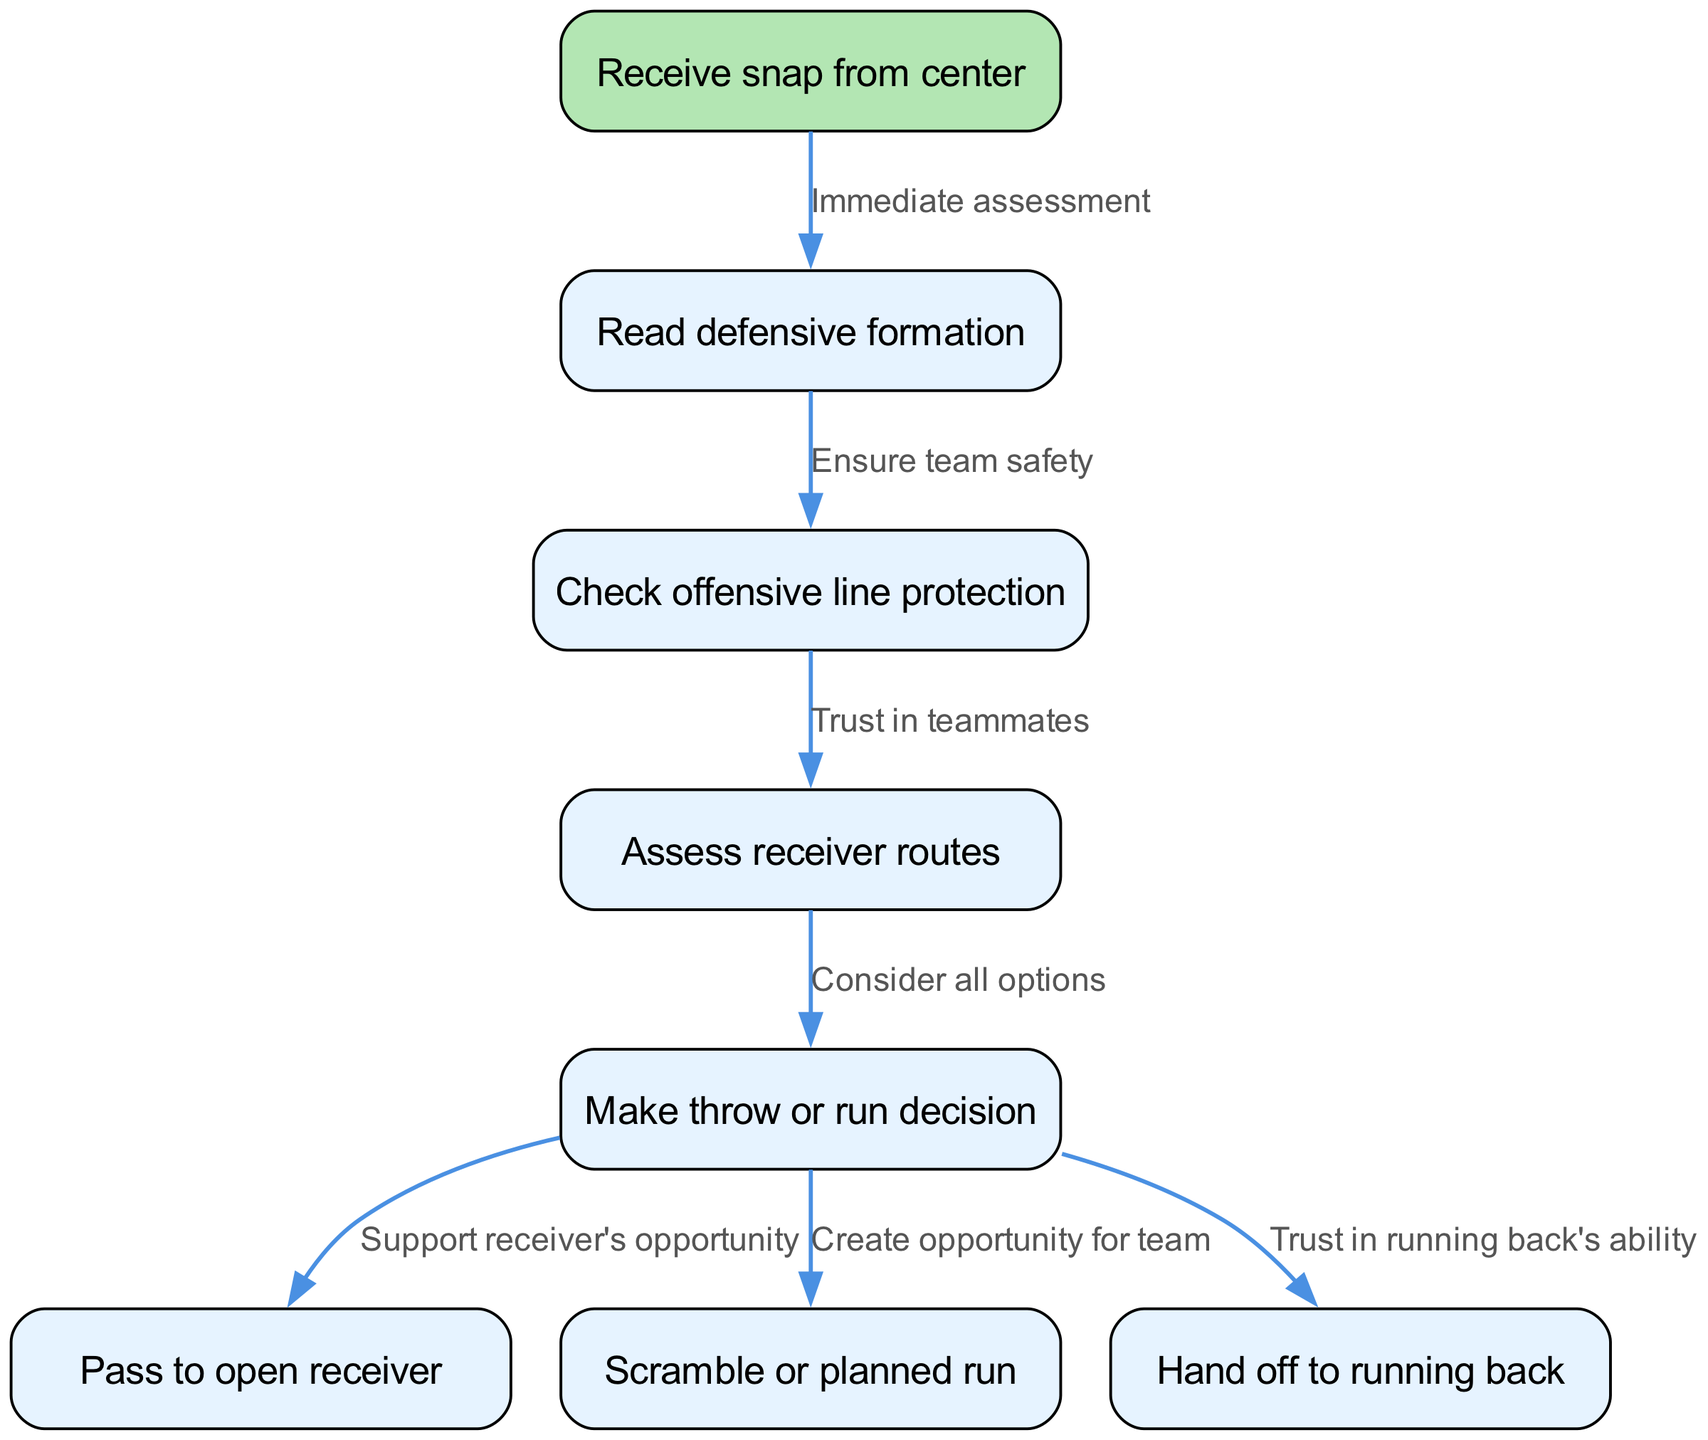What is the starting node of the flowchart? The starting node is "Snap," which indicates the first action in the quarterback's decision-making process after receiving the ball.
Answer: Snap How many total nodes are in the diagram? By counting the nodes listed, there are eight nodes involved in the flowchart process.
Answer: 8 What node comes after "ReadDefense"? The diagram specifies that after "ReadDefense," the next node is "ProtectionCheck," indicating a step focused on ensuring the safety of the quarterback.
Answer: ProtectionCheck Which node indicates a decision about running or passing the ball? The node "Decision" is where the quarterback makes choices about throwing or running the play, emphasizing strategic thinking.
Answer: Decision What is the relationship between "Decision" and "Throw"? The relationship is that "Decision" leads to "Throw," and the edge text indicates the action is made to support the opportunity of the receiver during the play.
Answer: Support receiver's opportunity What is the final action the quarterback can take according to the flowchart? The flowchart includes three possible final actions, but one of them specified for a decision is "Handoff," indicating trust in the running back.
Answer: Handoff Which node reflects the assessment of the offensive line protection? The node "ProtectionCheck" reflects the step where the quarterback assesses the offensive line's ability to protect him during the play.
Answer: ProtectionCheck What does the edge text from "ProtectionCheck" to "ReceiverRoutes" indicate? The edge text states "Trust in teammates," implying that after checking protection, the quarterback relies on his teammates' routes to proceed with the play.
Answer: Trust in teammates What decision type involves “scramble or planned run”? The diagram categorizes the "Run" decision as one of the choices available after assessing the situation during the "Decision" phase of the play.
Answer: Scramble or planned run 